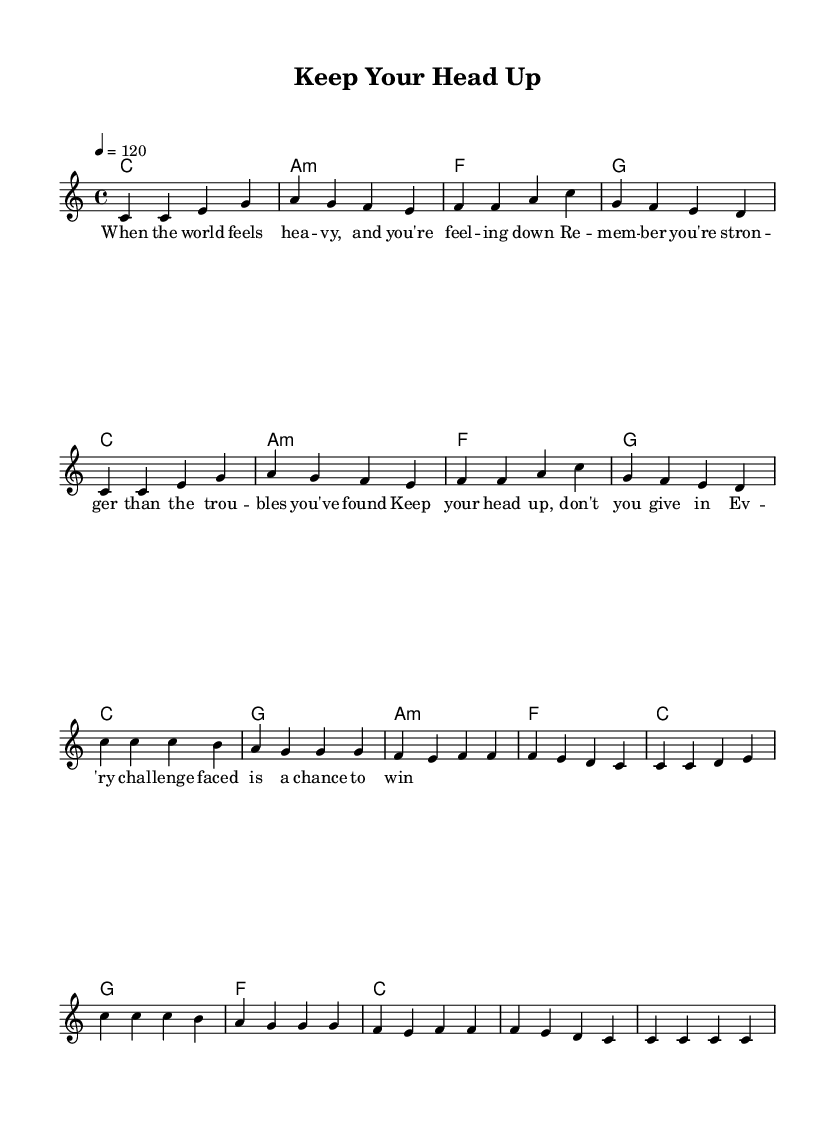What is the key signature of this music? The key signature is indicated at the beginning of the score. In this case, it shows no sharps or flats, which corresponds to C major.
Answer: C major What is the time signature of the piece? The time signature is found at the beginning of the score next to the key signature. It is written as "4/4", which indicates there are four beats in each measure and the quarter note gets one beat.
Answer: 4/4 What is the tempo marking for this piece? The tempo marking is located at the beginning of the score and is written as "4 = 120", which indicates a fast pace of 120 beats per minute.
Answer: 120 How many measures are there in the verse? To find the number of measures in the verse, we count the measures in the "melody" section labeled as the verse. There are a total of eight measures in the verse.
Answer: 8 What chords are used in the chorus? The chords for the chorus can be found in the "harmonies" section corresponding to the melody. The chords listed are C, G, A minor, and F.
Answer: C, G, A minor, F What is the first lyric line of the verse? The first lyric line is indicated in the "verseWords" section of the score. It is the first line after the title and is "When the world feels heavy, and you're feeling down".
Answer: When the world feels heavy, and you're feeling down How many times does the phrase "Keep your head up" repeat in the chorus? By examining the "chorusWords" section, we see that the phrase "Keep your head up" appears at the beginning and does not repeat again in the chorus lines provided. Therefore, it appears one time.
Answer: 1 